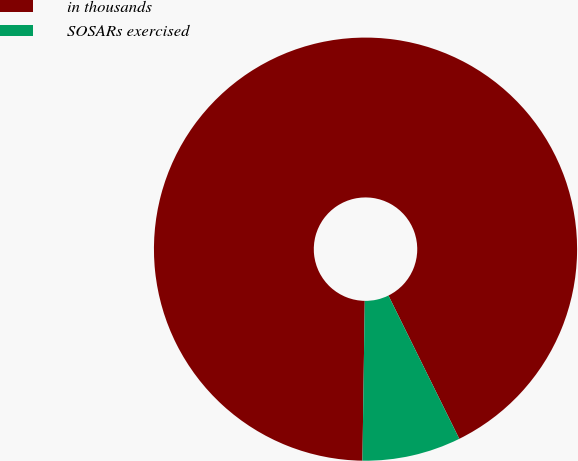Convert chart. <chart><loc_0><loc_0><loc_500><loc_500><pie_chart><fcel>in thousands<fcel>SOSARs exercised<nl><fcel>92.46%<fcel>7.54%<nl></chart> 